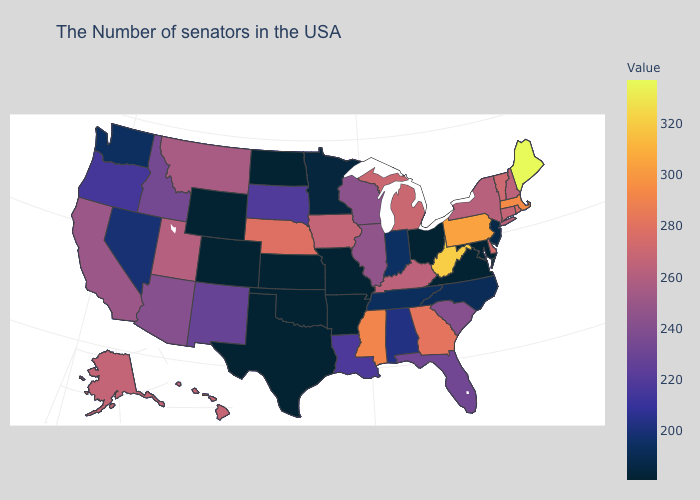Among the states that border West Virginia , does Kentucky have the lowest value?
Short answer required. No. Which states have the highest value in the USA?
Quick response, please. Maine. Which states hav the highest value in the Northeast?
Be succinct. Maine. Does Vermont have a lower value than Wisconsin?
Give a very brief answer. No. 